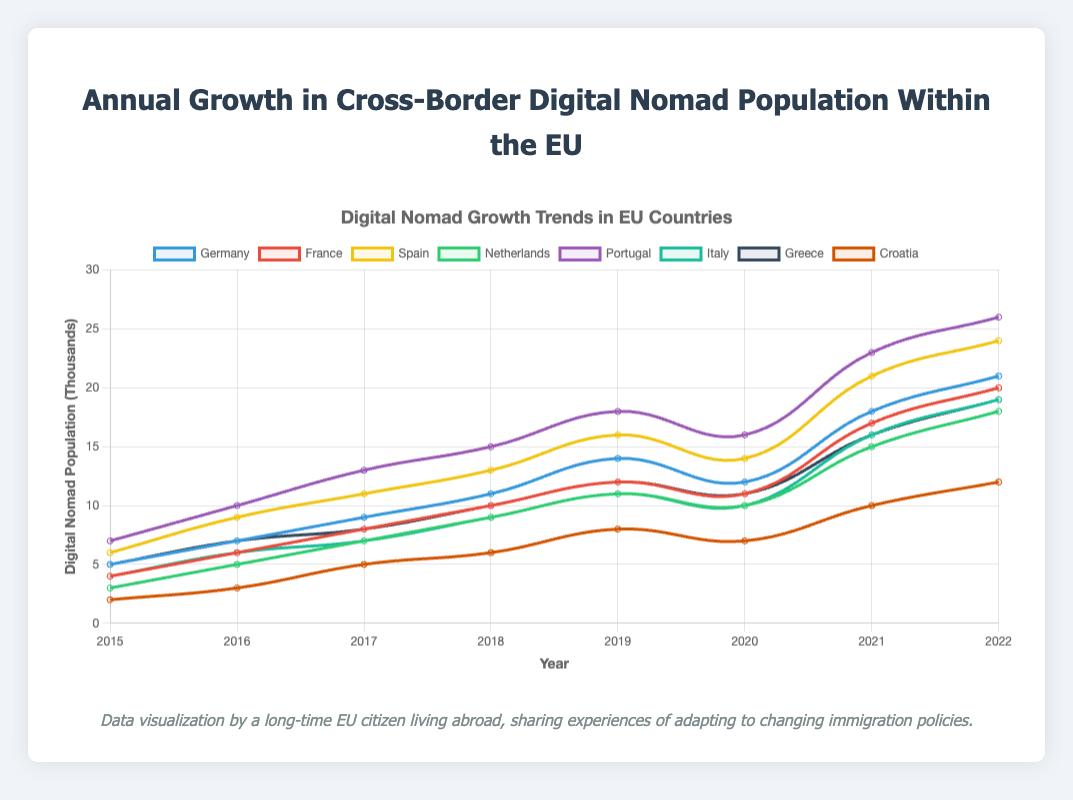Which country saw the highest growth in the digital nomad population between 2015 and 2022? To determine which country saw the highest growth, subtract the 2015 value from the 2022 value for each country: Germany (21-5=16), France (20-4=16), Spain (24-6=18), Netherlands (18-3=15), Portugal (26-7=19), Italy (19-4=15), Greece (19-5=14), Croatia (12-2=10). Portugal has the highest growth with 19 thousand.
Answer: Portugal Which year did Germany see its highest annual growth in digital nomad population? Look at the differences in Germany's data between consecutive years: 2015-2016 (2), 2016-2017 (2), 2017-2018 (2), 2018-2019 (3), 2019-2020 (-2), 2020-2021 (6), 2021-2022 (3). The highest annual growth was between 2020 and 2021 with a growth of 6 thousand.
Answer: 2020-2021 In 2020, which country had more digital nomads: France or Italy? By comparing the figures for 2020, France had 11 thousand digital nomads and Italy had 10 thousand. Therefore, France had more digital nomads in 2020.
Answer: France What is the average annual growth in the digital nomad population in Spain from 2015 to 2022? Sum the annual growths and divide by the number of years: (6+9+11+13+16+14+21+24 - 6) / 7 = 18/7 ≈ 2.57 thousand per year. The average annual growth is approximately 2.57 thousand.
Answer: 2.57 Which countries had the same digital nomad population in 2018? Looking at the 2018 values: Germany (11), France (10), Spain (13), Netherlands (9), Portugal (15), Italy (9), Greece (10), Croatia (6), we see that the Netherlands and Italy both had a digital nomad population of 9 thousand.
Answer: Netherlands and Italy Between which consecutive years did Portugal see a decrease in its digital nomad population? Analyze the yearly data for Portugal: 2015-2016 (+3), 2016-2017 (+3), 2017-2018 (+2), 2018-2019 (+3), 2019-2020 (-2), 2020-2021 (+7), 2021-2022 (+3). The population decreased from 2019 to 2020 by 2 thousand.
Answer: 2019-2020 